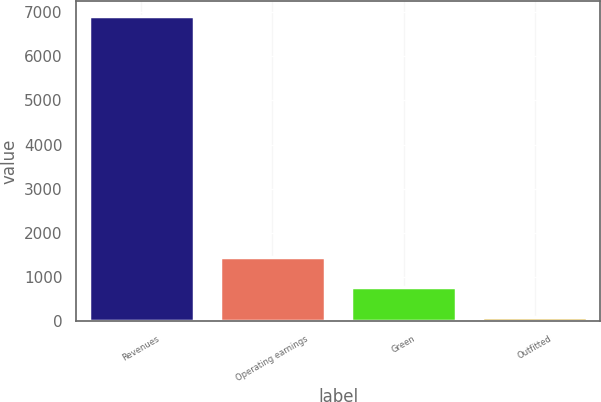Convert chart. <chart><loc_0><loc_0><loc_500><loc_500><bar_chart><fcel>Revenues<fcel>Operating earnings<fcel>Green<fcel>Outfitted<nl><fcel>6912<fcel>1457.6<fcel>775.8<fcel>94<nl></chart> 